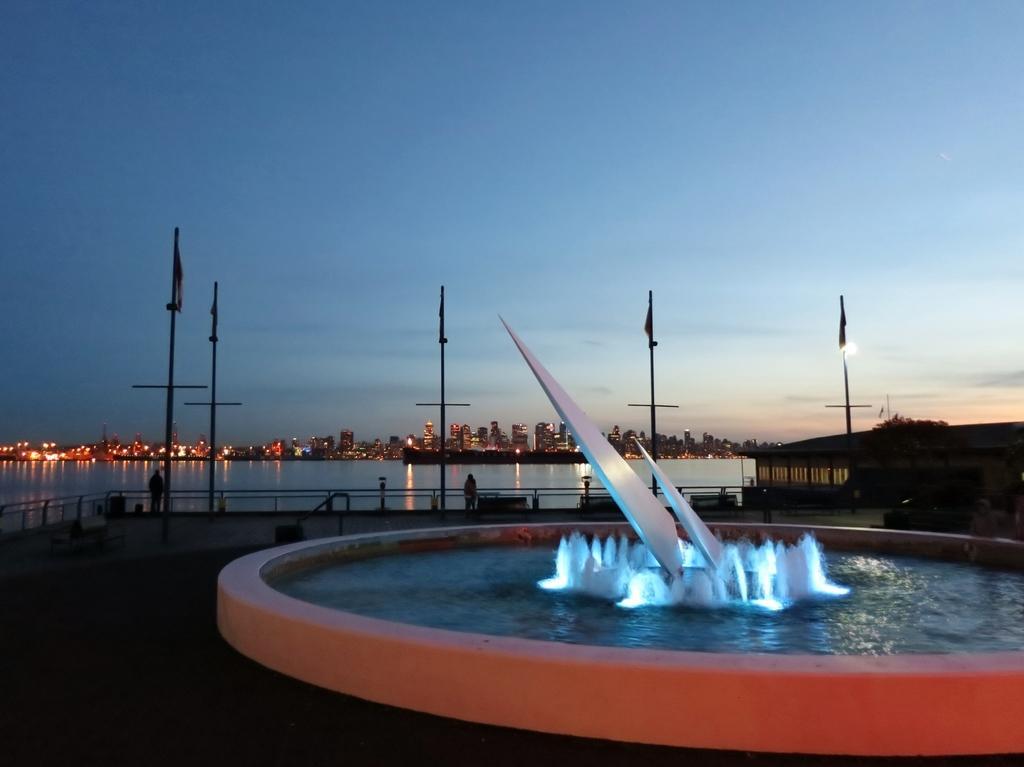Can you describe this image briefly? In this image I can see the water. In the background, I can see the buildings with lights and clouds in the sky. 